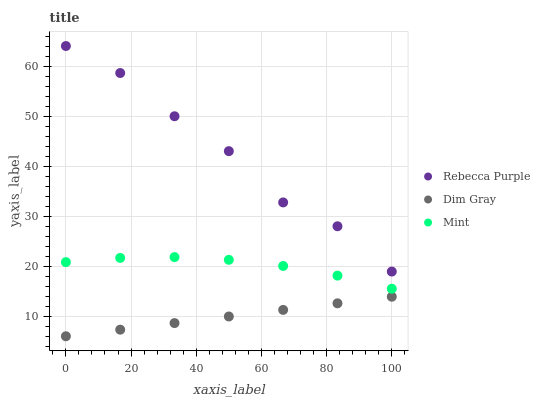Does Dim Gray have the minimum area under the curve?
Answer yes or no. Yes. Does Rebecca Purple have the maximum area under the curve?
Answer yes or no. Yes. Does Mint have the minimum area under the curve?
Answer yes or no. No. Does Mint have the maximum area under the curve?
Answer yes or no. No. Is Dim Gray the smoothest?
Answer yes or no. Yes. Is Rebecca Purple the roughest?
Answer yes or no. Yes. Is Mint the smoothest?
Answer yes or no. No. Is Mint the roughest?
Answer yes or no. No. Does Dim Gray have the lowest value?
Answer yes or no. Yes. Does Mint have the lowest value?
Answer yes or no. No. Does Rebecca Purple have the highest value?
Answer yes or no. Yes. Does Mint have the highest value?
Answer yes or no. No. Is Mint less than Rebecca Purple?
Answer yes or no. Yes. Is Rebecca Purple greater than Mint?
Answer yes or no. Yes. Does Mint intersect Rebecca Purple?
Answer yes or no. No. 